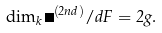<formula> <loc_0><loc_0><loc_500><loc_500>\dim _ { k } \Omega ^ { ( 2 n d ) } / d F = 2 g .</formula> 